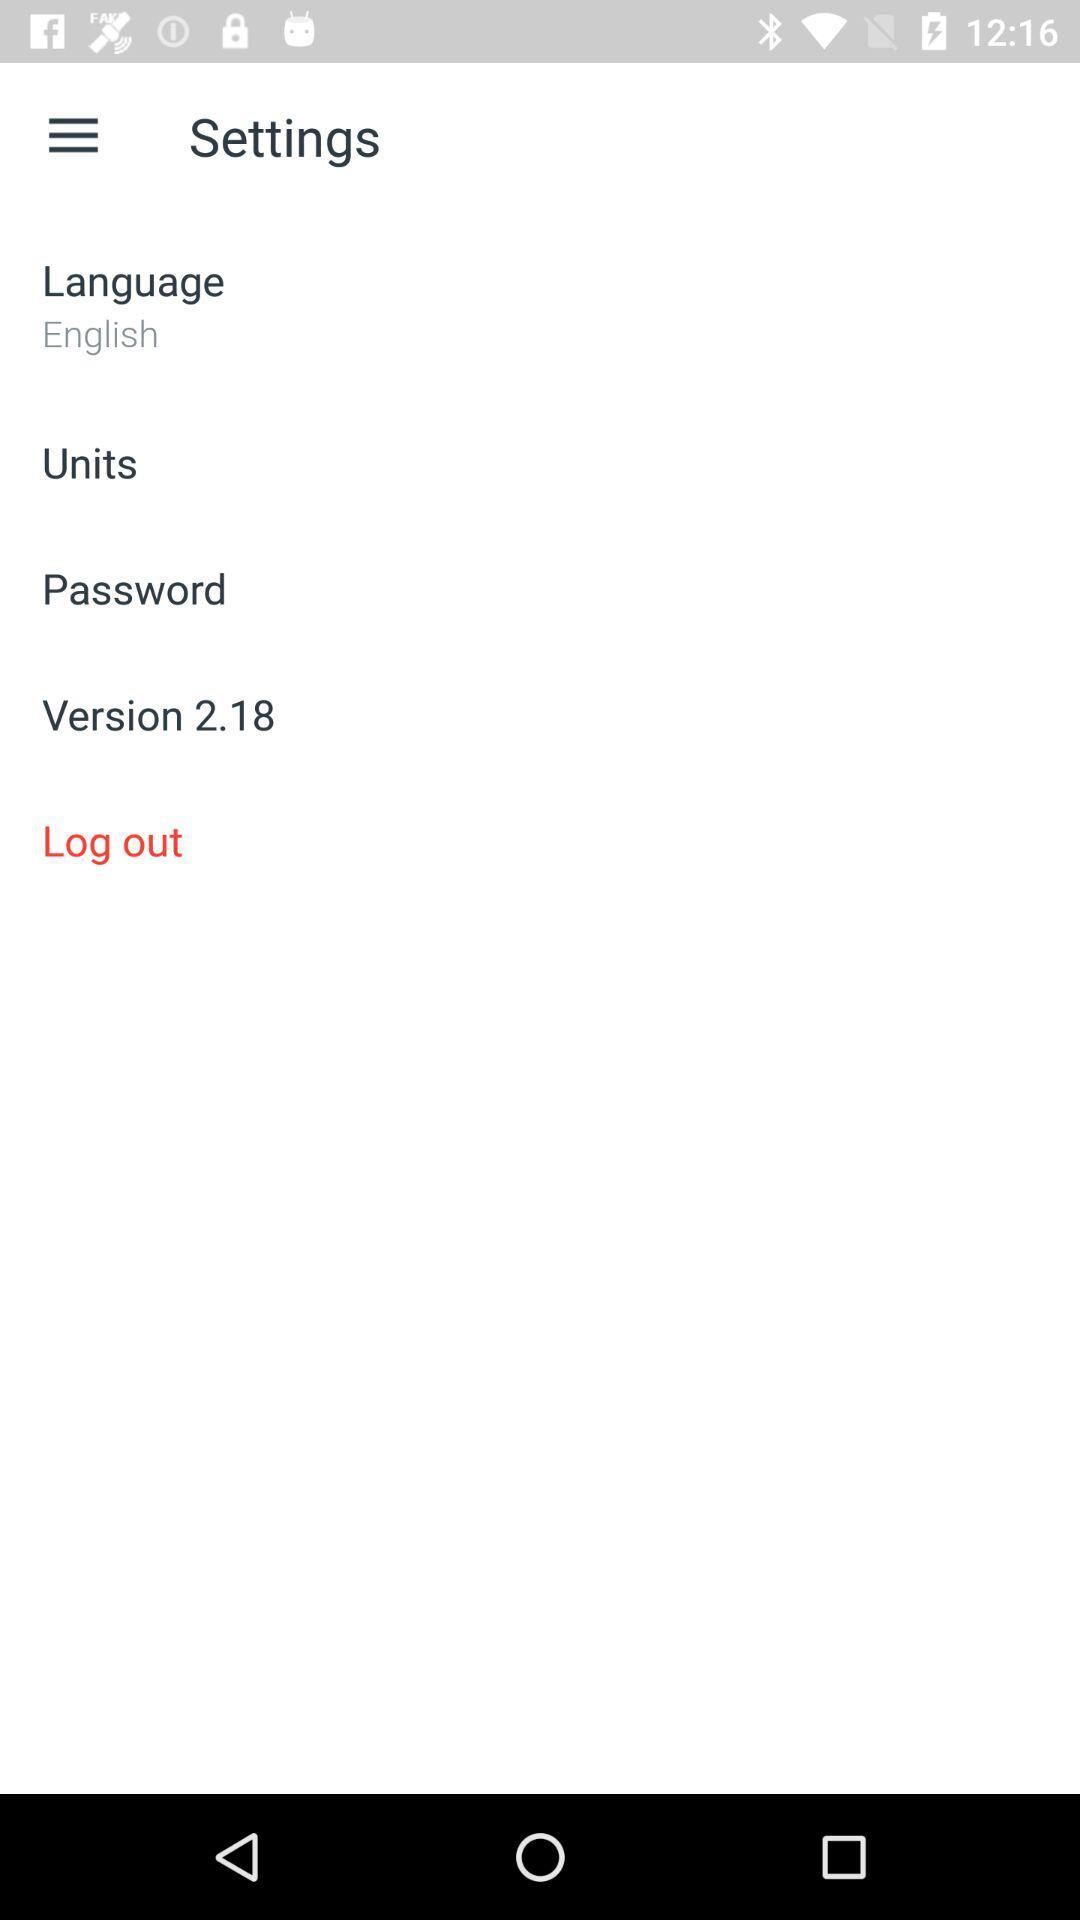What is the version? The version is 2.18. 